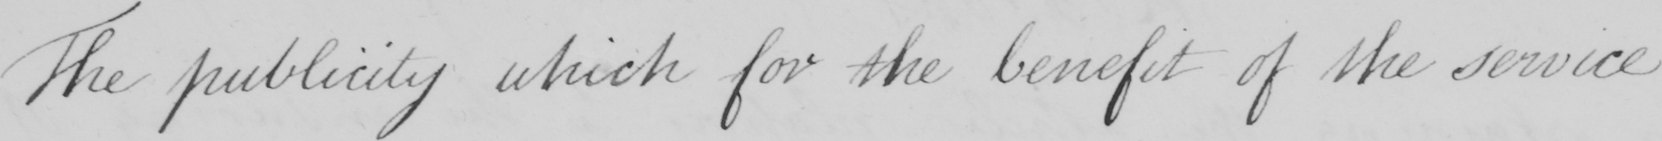Please transcribe the handwritten text in this image. The publicity which for the benefit of the service 